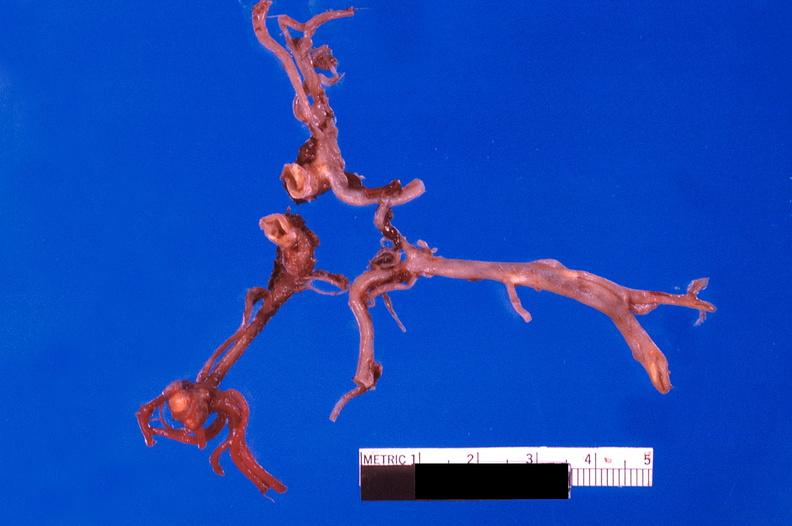what is present?
Answer the question using a single word or phrase. Cardiovascular 